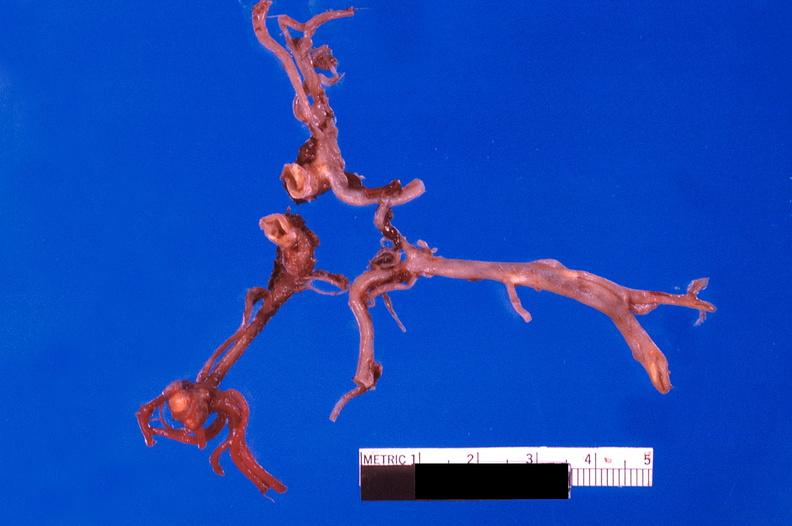what is present?
Answer the question using a single word or phrase. Cardiovascular 